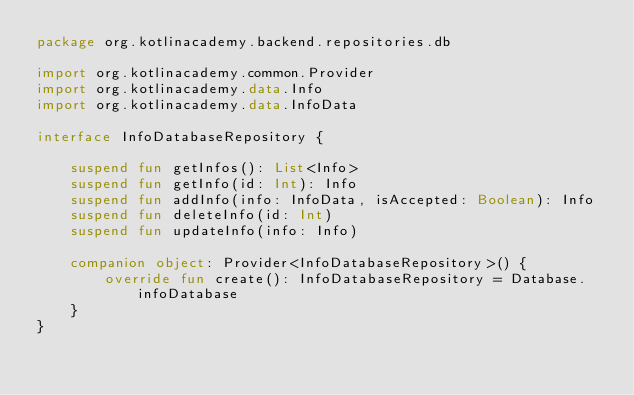<code> <loc_0><loc_0><loc_500><loc_500><_Kotlin_>package org.kotlinacademy.backend.repositories.db

import org.kotlinacademy.common.Provider
import org.kotlinacademy.data.Info
import org.kotlinacademy.data.InfoData

interface InfoDatabaseRepository {

    suspend fun getInfos(): List<Info>
    suspend fun getInfo(id: Int): Info
    suspend fun addInfo(info: InfoData, isAccepted: Boolean): Info
    suspend fun deleteInfo(id: Int)
    suspend fun updateInfo(info: Info)

    companion object: Provider<InfoDatabaseRepository>() {
        override fun create(): InfoDatabaseRepository = Database.infoDatabase
    }
}</code> 